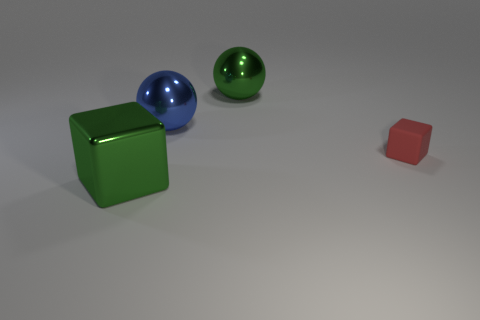There is a big object that is in front of the tiny red thing; what color is it?
Your answer should be very brief. Green. What color is the big shiny thing that is the same shape as the tiny rubber thing?
Make the answer very short. Green. There is a cube that is behind the large green object in front of the tiny matte thing; what number of metal objects are in front of it?
Keep it short and to the point. 1. Is there anything else that is made of the same material as the small thing?
Your response must be concise. No. Is the number of green spheres that are left of the green sphere less than the number of tiny gray rubber balls?
Your answer should be compact. No. Does the small matte thing have the same color as the big cube?
Make the answer very short. No. The green metallic thing that is the same shape as the tiny red matte thing is what size?
Provide a succinct answer. Large. What number of green balls have the same material as the small thing?
Keep it short and to the point. 0. Is the material of the tiny red cube that is in front of the big blue metallic sphere the same as the green block?
Give a very brief answer. No. Are there the same number of green shiny spheres in front of the green block and large green metallic cubes?
Provide a succinct answer. No. 